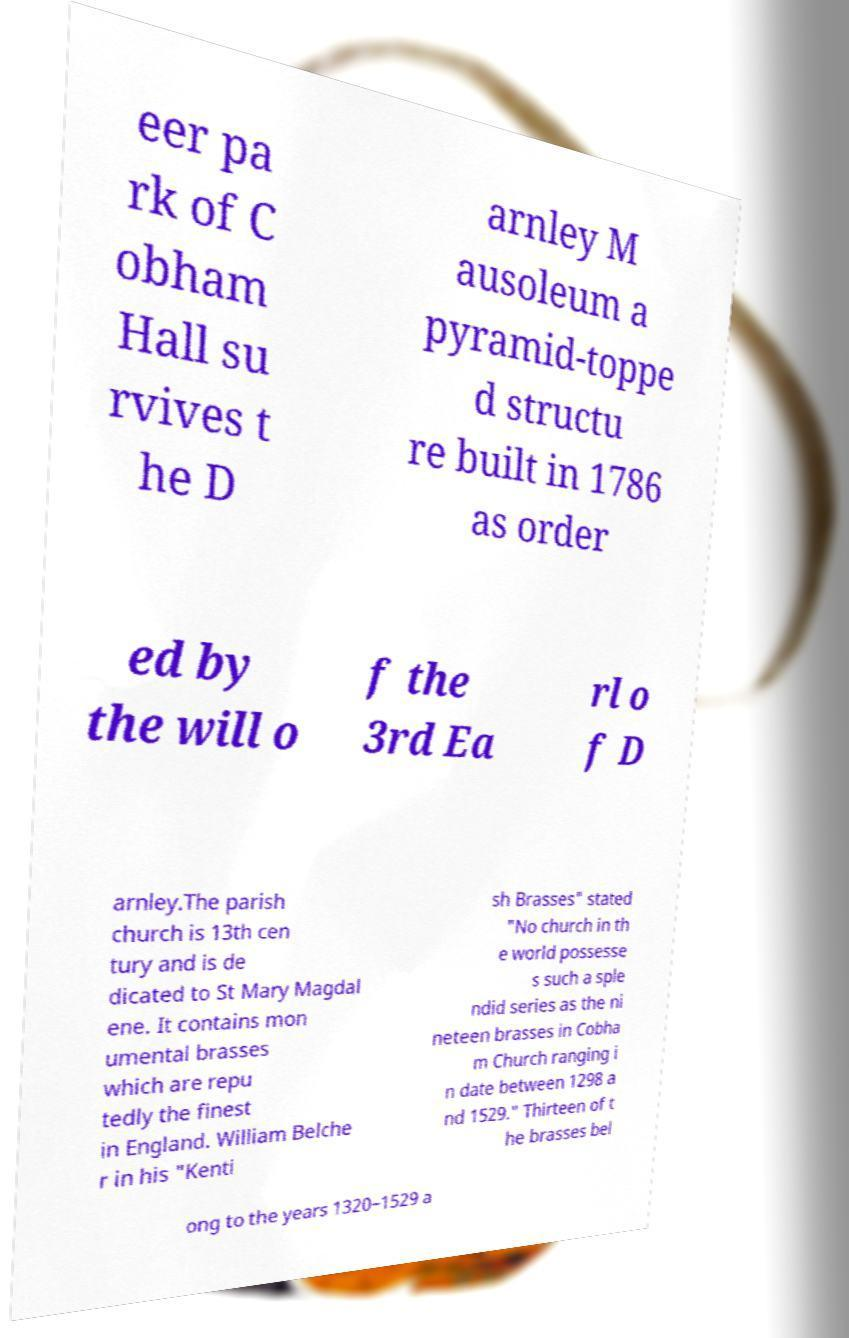Can you accurately transcribe the text from the provided image for me? eer pa rk of C obham Hall su rvives t he D arnley M ausoleum a pyramid-toppe d structu re built in 1786 as order ed by the will o f the 3rd Ea rl o f D arnley.The parish church is 13th cen tury and is de dicated to St Mary Magdal ene. It contains mon umental brasses which are repu tedly the finest in England. William Belche r in his "Kenti sh Brasses" stated "No church in th e world possesse s such a sple ndid series as the ni neteen brasses in Cobha m Church ranging i n date between 1298 a nd 1529." Thirteen of t he brasses bel ong to the years 1320–1529 a 